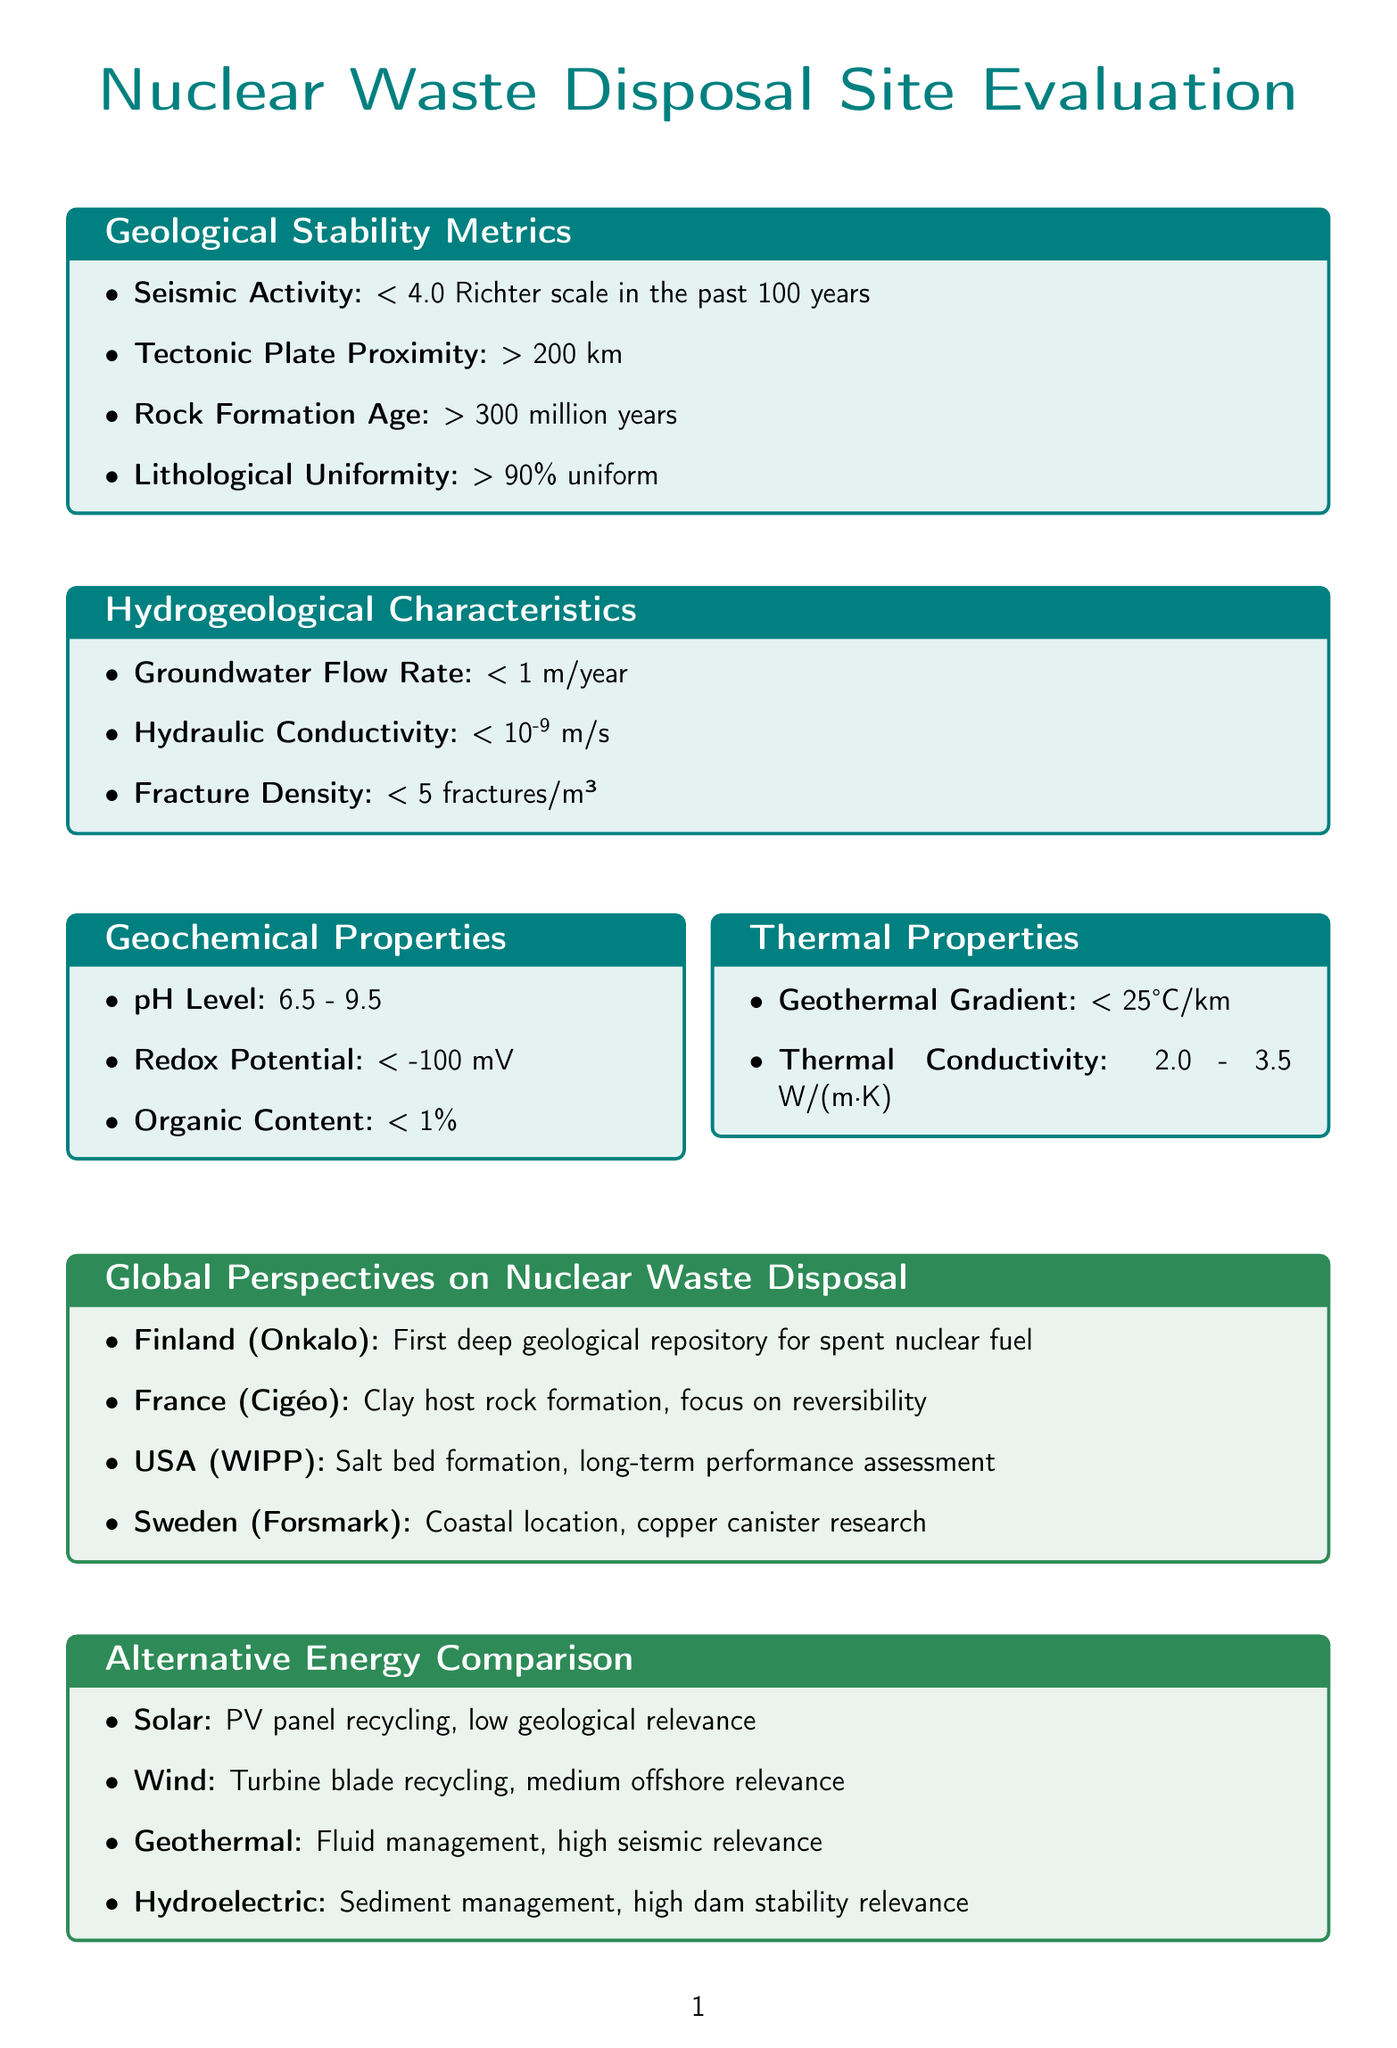What is the maximum acceptable seismic activity level for a waste disposal site? The document states that the acceptable range for seismic activity is less than 4.0 on the Richter scale in the past 100 years.
Answer: < 4.0 Richter scale What is the minimum distance a nuclear waste disposal site should be from tectonic plate boundaries? According to the document, disposal sites should be more than 200 kilometers away from active tectonic plate boundaries.
Answer: > 200 km What type of geological setting is Finland's Onkalo known for? The document mentions that Finland's Onkalo is the first deep geological repository for spent nuclear fuel.
Answer: First deep geological repository What is the maximum acceptable groundwater flow rate for a site? The document indicates that the acceptable groundwater flow rate should be less than 1 meter per year.
Answer: < 1 m/year What is the acceptable age for the host rock formation? The document states that the rock formation should be older than 300 million years.
Answer: > 300 million years What type of geological formation does the United States' WIPP site utilize? The document specifies that the Waste Isolation Pilot Plant in the United States is located in a salt bed formation.
Answer: Salt bed formation Which alternative energy source has high geological stability relevance due to seismic activity risks? The document highlights geothermal energy as having high geological stability relevance because of seismic activity risks.
Answer: Geothermal What percentage of lithological uniformity is required for a waste disposal site? The acceptable range for lithological uniformity is greater than 90 percent.
Answer: > 90% uniform How does the document propose to engage future generations regarding nuclear waste? The document states that the engagement strategy for future generations includes developing universal warning symbols and time capsules.
Answer: Universal warning symbols and time capsules 